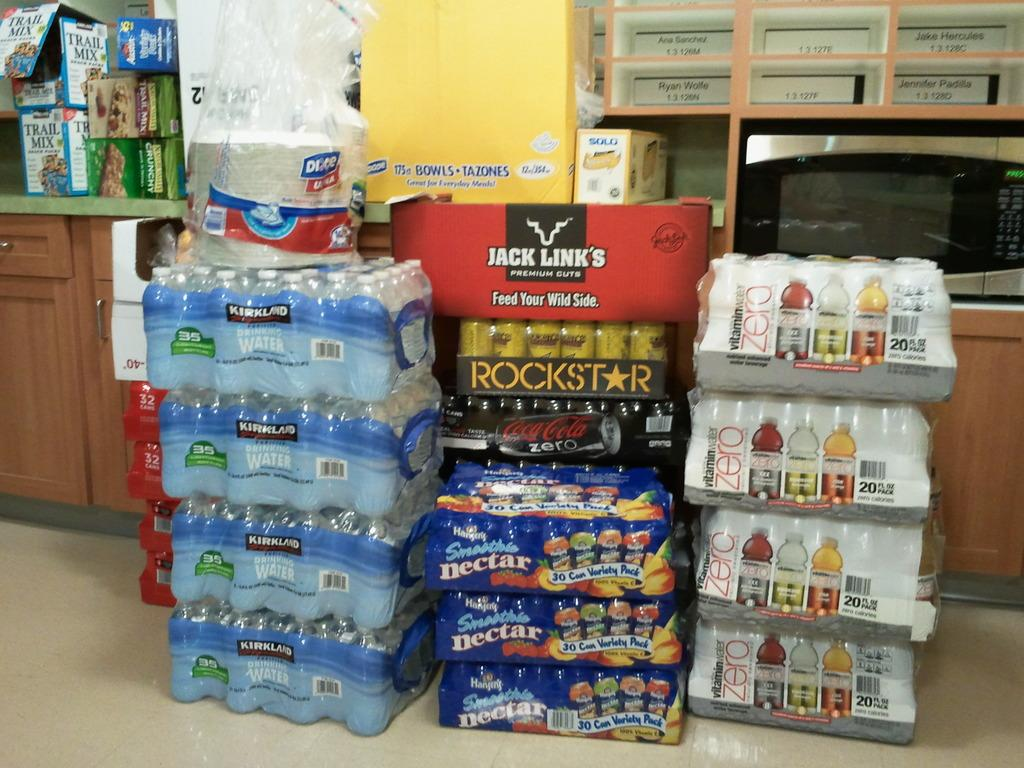<image>
Describe the image concisely. A stack of packaged drinks on the floor including Kirkland bottled drinking water and RockStar drinks. 